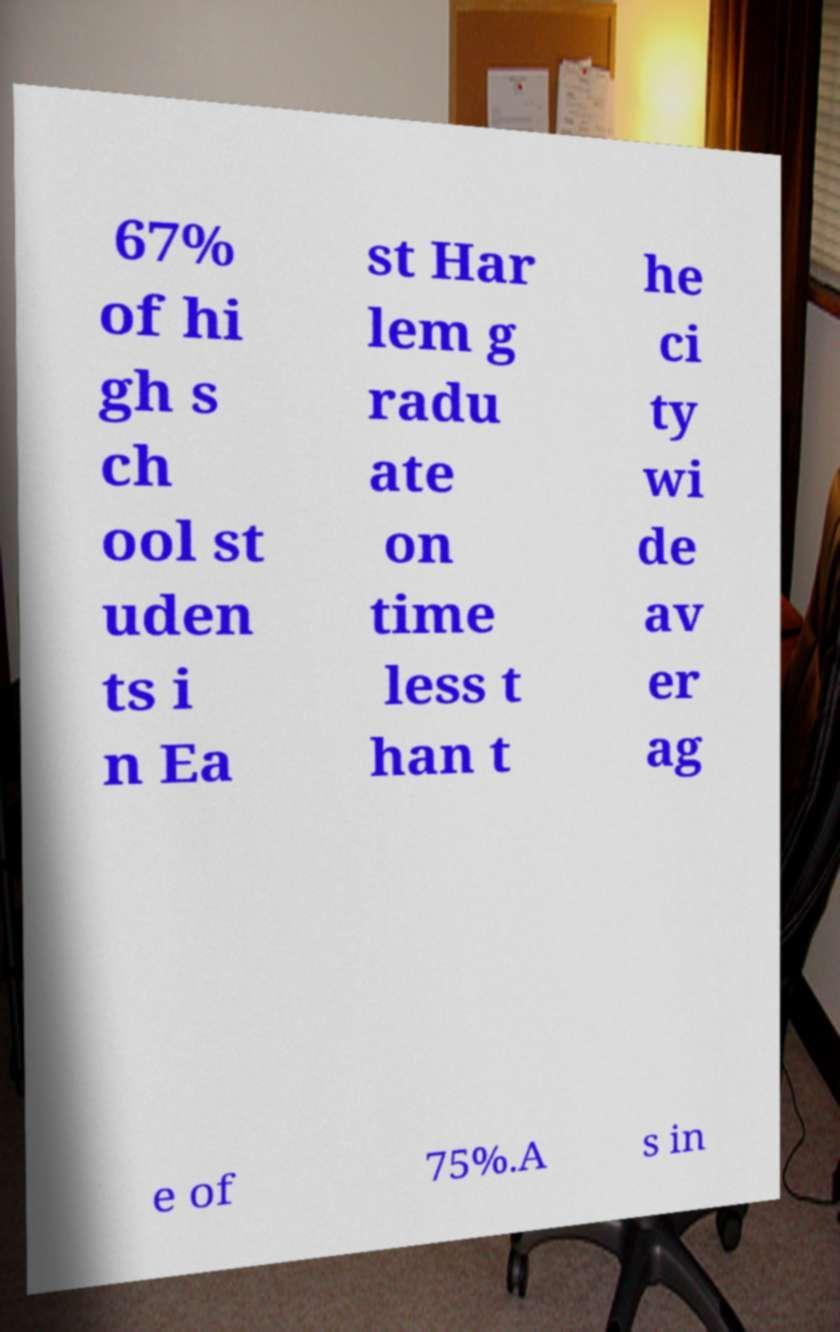Can you accurately transcribe the text from the provided image for me? 67% of hi gh s ch ool st uden ts i n Ea st Har lem g radu ate on time less t han t he ci ty wi de av er ag e of 75%.A s in 